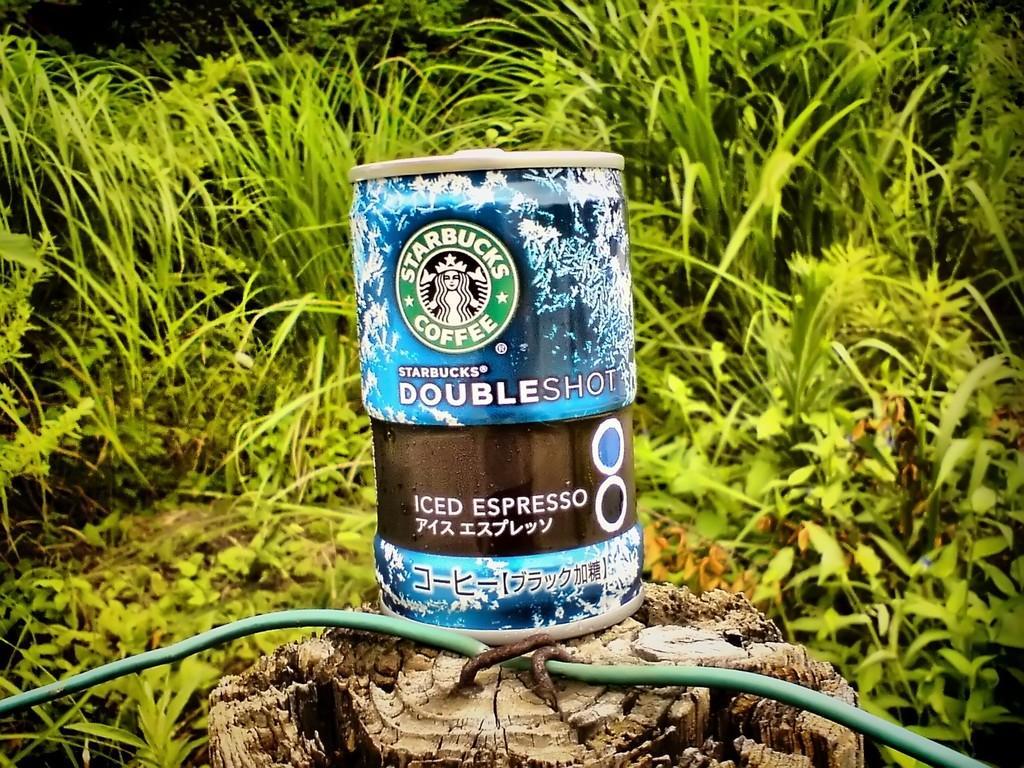Could you give a brief overview of what you see in this image? In the center of the image we can see an object and wire, wood trunk are there. In the background of the image we can see some plants are present. 